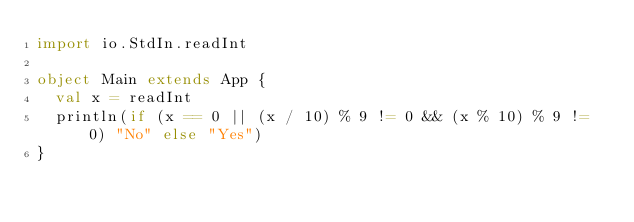Convert code to text. <code><loc_0><loc_0><loc_500><loc_500><_Scala_>import io.StdIn.readInt

object Main extends App {
  val x = readInt
  println(if (x == 0 || (x / 10) % 9 != 0 && (x % 10) % 9 != 0) "No" else "Yes")
}</code> 